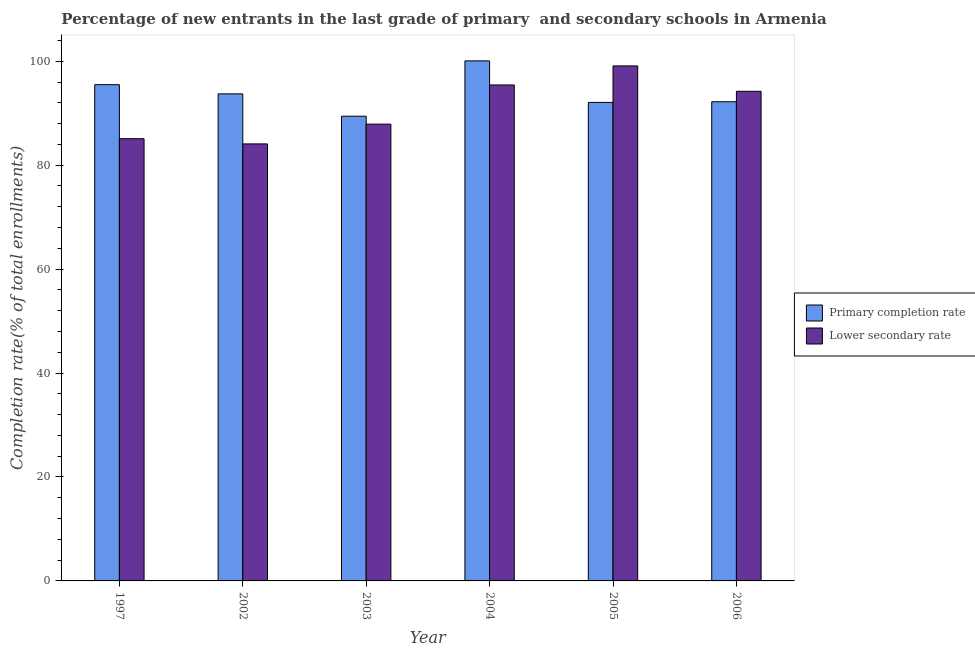How many different coloured bars are there?
Provide a succinct answer. 2. Are the number of bars per tick equal to the number of legend labels?
Your answer should be compact. Yes. Are the number of bars on each tick of the X-axis equal?
Your answer should be compact. Yes. How many bars are there on the 6th tick from the left?
Your answer should be compact. 2. What is the completion rate in primary schools in 1997?
Offer a very short reply. 95.5. Across all years, what is the maximum completion rate in primary schools?
Provide a succinct answer. 100.08. Across all years, what is the minimum completion rate in primary schools?
Make the answer very short. 89.43. In which year was the completion rate in secondary schools minimum?
Give a very brief answer. 2002. What is the total completion rate in primary schools in the graph?
Ensure brevity in your answer.  563.02. What is the difference between the completion rate in primary schools in 2002 and that in 2003?
Offer a terse response. 4.3. What is the difference between the completion rate in secondary schools in 1997 and the completion rate in primary schools in 2002?
Offer a terse response. 1. What is the average completion rate in secondary schools per year?
Your answer should be compact. 90.98. In the year 2006, what is the difference between the completion rate in primary schools and completion rate in secondary schools?
Ensure brevity in your answer.  0. In how many years, is the completion rate in primary schools greater than 64 %?
Offer a terse response. 6. What is the ratio of the completion rate in secondary schools in 2002 to that in 2004?
Your answer should be very brief. 0.88. Is the completion rate in primary schools in 2002 less than that in 2006?
Make the answer very short. No. What is the difference between the highest and the second highest completion rate in secondary schools?
Provide a succinct answer. 3.66. What is the difference between the highest and the lowest completion rate in primary schools?
Ensure brevity in your answer.  10.65. What does the 2nd bar from the left in 2002 represents?
Your response must be concise. Lower secondary rate. What does the 2nd bar from the right in 2006 represents?
Your answer should be compact. Primary completion rate. How many bars are there?
Ensure brevity in your answer.  12. Does the graph contain grids?
Offer a very short reply. No. What is the title of the graph?
Provide a short and direct response. Percentage of new entrants in the last grade of primary  and secondary schools in Armenia. What is the label or title of the Y-axis?
Your response must be concise. Completion rate(% of total enrollments). What is the Completion rate(% of total enrollments) of Primary completion rate in 1997?
Offer a terse response. 95.5. What is the Completion rate(% of total enrollments) of Lower secondary rate in 1997?
Make the answer very short. 85.1. What is the Completion rate(% of total enrollments) in Primary completion rate in 2002?
Provide a short and direct response. 93.73. What is the Completion rate(% of total enrollments) of Lower secondary rate in 2002?
Keep it short and to the point. 84.1. What is the Completion rate(% of total enrollments) in Primary completion rate in 2003?
Offer a terse response. 89.43. What is the Completion rate(% of total enrollments) in Lower secondary rate in 2003?
Provide a succinct answer. 87.91. What is the Completion rate(% of total enrollments) of Primary completion rate in 2004?
Your response must be concise. 100.08. What is the Completion rate(% of total enrollments) in Lower secondary rate in 2004?
Keep it short and to the point. 95.44. What is the Completion rate(% of total enrollments) of Primary completion rate in 2005?
Offer a very short reply. 92.08. What is the Completion rate(% of total enrollments) of Lower secondary rate in 2005?
Ensure brevity in your answer.  99.1. What is the Completion rate(% of total enrollments) in Primary completion rate in 2006?
Keep it short and to the point. 92.21. What is the Completion rate(% of total enrollments) of Lower secondary rate in 2006?
Your answer should be very brief. 94.22. Across all years, what is the maximum Completion rate(% of total enrollments) of Primary completion rate?
Your response must be concise. 100.08. Across all years, what is the maximum Completion rate(% of total enrollments) in Lower secondary rate?
Your response must be concise. 99.1. Across all years, what is the minimum Completion rate(% of total enrollments) of Primary completion rate?
Make the answer very short. 89.43. Across all years, what is the minimum Completion rate(% of total enrollments) in Lower secondary rate?
Your answer should be compact. 84.1. What is the total Completion rate(% of total enrollments) of Primary completion rate in the graph?
Your response must be concise. 563.02. What is the total Completion rate(% of total enrollments) of Lower secondary rate in the graph?
Your response must be concise. 545.87. What is the difference between the Completion rate(% of total enrollments) in Primary completion rate in 1997 and that in 2002?
Your answer should be very brief. 1.77. What is the difference between the Completion rate(% of total enrollments) of Primary completion rate in 1997 and that in 2003?
Keep it short and to the point. 6.07. What is the difference between the Completion rate(% of total enrollments) of Lower secondary rate in 1997 and that in 2003?
Offer a terse response. -2.81. What is the difference between the Completion rate(% of total enrollments) of Primary completion rate in 1997 and that in 2004?
Offer a terse response. -4.58. What is the difference between the Completion rate(% of total enrollments) in Lower secondary rate in 1997 and that in 2004?
Your answer should be compact. -10.34. What is the difference between the Completion rate(% of total enrollments) in Primary completion rate in 1997 and that in 2005?
Provide a short and direct response. 3.42. What is the difference between the Completion rate(% of total enrollments) in Lower secondary rate in 1997 and that in 2005?
Keep it short and to the point. -14.01. What is the difference between the Completion rate(% of total enrollments) of Primary completion rate in 1997 and that in 2006?
Give a very brief answer. 3.29. What is the difference between the Completion rate(% of total enrollments) of Lower secondary rate in 1997 and that in 2006?
Give a very brief answer. -9.12. What is the difference between the Completion rate(% of total enrollments) of Primary completion rate in 2002 and that in 2003?
Provide a succinct answer. 4.3. What is the difference between the Completion rate(% of total enrollments) in Lower secondary rate in 2002 and that in 2003?
Ensure brevity in your answer.  -3.81. What is the difference between the Completion rate(% of total enrollments) in Primary completion rate in 2002 and that in 2004?
Offer a very short reply. -6.35. What is the difference between the Completion rate(% of total enrollments) in Lower secondary rate in 2002 and that in 2004?
Keep it short and to the point. -11.34. What is the difference between the Completion rate(% of total enrollments) in Primary completion rate in 2002 and that in 2005?
Offer a terse response. 1.64. What is the difference between the Completion rate(% of total enrollments) in Lower secondary rate in 2002 and that in 2005?
Offer a terse response. -15.01. What is the difference between the Completion rate(% of total enrollments) in Primary completion rate in 2002 and that in 2006?
Your answer should be very brief. 1.51. What is the difference between the Completion rate(% of total enrollments) in Lower secondary rate in 2002 and that in 2006?
Offer a terse response. -10.13. What is the difference between the Completion rate(% of total enrollments) of Primary completion rate in 2003 and that in 2004?
Provide a short and direct response. -10.65. What is the difference between the Completion rate(% of total enrollments) in Lower secondary rate in 2003 and that in 2004?
Your answer should be compact. -7.53. What is the difference between the Completion rate(% of total enrollments) in Primary completion rate in 2003 and that in 2005?
Offer a very short reply. -2.65. What is the difference between the Completion rate(% of total enrollments) of Lower secondary rate in 2003 and that in 2005?
Offer a very short reply. -11.2. What is the difference between the Completion rate(% of total enrollments) in Primary completion rate in 2003 and that in 2006?
Offer a very short reply. -2.78. What is the difference between the Completion rate(% of total enrollments) of Lower secondary rate in 2003 and that in 2006?
Offer a very short reply. -6.32. What is the difference between the Completion rate(% of total enrollments) of Primary completion rate in 2004 and that in 2005?
Keep it short and to the point. 7.99. What is the difference between the Completion rate(% of total enrollments) in Lower secondary rate in 2004 and that in 2005?
Offer a terse response. -3.66. What is the difference between the Completion rate(% of total enrollments) of Primary completion rate in 2004 and that in 2006?
Provide a short and direct response. 7.86. What is the difference between the Completion rate(% of total enrollments) of Lower secondary rate in 2004 and that in 2006?
Make the answer very short. 1.22. What is the difference between the Completion rate(% of total enrollments) in Primary completion rate in 2005 and that in 2006?
Give a very brief answer. -0.13. What is the difference between the Completion rate(% of total enrollments) in Lower secondary rate in 2005 and that in 2006?
Provide a short and direct response. 4.88. What is the difference between the Completion rate(% of total enrollments) of Primary completion rate in 1997 and the Completion rate(% of total enrollments) of Lower secondary rate in 2002?
Provide a short and direct response. 11.4. What is the difference between the Completion rate(% of total enrollments) of Primary completion rate in 1997 and the Completion rate(% of total enrollments) of Lower secondary rate in 2003?
Offer a very short reply. 7.59. What is the difference between the Completion rate(% of total enrollments) of Primary completion rate in 1997 and the Completion rate(% of total enrollments) of Lower secondary rate in 2004?
Offer a terse response. 0.06. What is the difference between the Completion rate(% of total enrollments) in Primary completion rate in 1997 and the Completion rate(% of total enrollments) in Lower secondary rate in 2005?
Make the answer very short. -3.61. What is the difference between the Completion rate(% of total enrollments) of Primary completion rate in 1997 and the Completion rate(% of total enrollments) of Lower secondary rate in 2006?
Offer a terse response. 1.27. What is the difference between the Completion rate(% of total enrollments) of Primary completion rate in 2002 and the Completion rate(% of total enrollments) of Lower secondary rate in 2003?
Ensure brevity in your answer.  5.82. What is the difference between the Completion rate(% of total enrollments) in Primary completion rate in 2002 and the Completion rate(% of total enrollments) in Lower secondary rate in 2004?
Make the answer very short. -1.72. What is the difference between the Completion rate(% of total enrollments) of Primary completion rate in 2002 and the Completion rate(% of total enrollments) of Lower secondary rate in 2005?
Ensure brevity in your answer.  -5.38. What is the difference between the Completion rate(% of total enrollments) in Primary completion rate in 2002 and the Completion rate(% of total enrollments) in Lower secondary rate in 2006?
Offer a very short reply. -0.5. What is the difference between the Completion rate(% of total enrollments) in Primary completion rate in 2003 and the Completion rate(% of total enrollments) in Lower secondary rate in 2004?
Provide a succinct answer. -6.01. What is the difference between the Completion rate(% of total enrollments) of Primary completion rate in 2003 and the Completion rate(% of total enrollments) of Lower secondary rate in 2005?
Provide a short and direct response. -9.68. What is the difference between the Completion rate(% of total enrollments) of Primary completion rate in 2003 and the Completion rate(% of total enrollments) of Lower secondary rate in 2006?
Offer a terse response. -4.8. What is the difference between the Completion rate(% of total enrollments) of Primary completion rate in 2004 and the Completion rate(% of total enrollments) of Lower secondary rate in 2005?
Provide a succinct answer. 0.97. What is the difference between the Completion rate(% of total enrollments) of Primary completion rate in 2004 and the Completion rate(% of total enrollments) of Lower secondary rate in 2006?
Keep it short and to the point. 5.85. What is the difference between the Completion rate(% of total enrollments) of Primary completion rate in 2005 and the Completion rate(% of total enrollments) of Lower secondary rate in 2006?
Keep it short and to the point. -2.14. What is the average Completion rate(% of total enrollments) in Primary completion rate per year?
Provide a succinct answer. 93.84. What is the average Completion rate(% of total enrollments) in Lower secondary rate per year?
Provide a short and direct response. 90.98. In the year 1997, what is the difference between the Completion rate(% of total enrollments) of Primary completion rate and Completion rate(% of total enrollments) of Lower secondary rate?
Your answer should be very brief. 10.4. In the year 2002, what is the difference between the Completion rate(% of total enrollments) of Primary completion rate and Completion rate(% of total enrollments) of Lower secondary rate?
Give a very brief answer. 9.63. In the year 2003, what is the difference between the Completion rate(% of total enrollments) in Primary completion rate and Completion rate(% of total enrollments) in Lower secondary rate?
Provide a short and direct response. 1.52. In the year 2004, what is the difference between the Completion rate(% of total enrollments) in Primary completion rate and Completion rate(% of total enrollments) in Lower secondary rate?
Your response must be concise. 4.63. In the year 2005, what is the difference between the Completion rate(% of total enrollments) in Primary completion rate and Completion rate(% of total enrollments) in Lower secondary rate?
Provide a succinct answer. -7.02. In the year 2006, what is the difference between the Completion rate(% of total enrollments) in Primary completion rate and Completion rate(% of total enrollments) in Lower secondary rate?
Offer a very short reply. -2.01. What is the ratio of the Completion rate(% of total enrollments) of Primary completion rate in 1997 to that in 2002?
Ensure brevity in your answer.  1.02. What is the ratio of the Completion rate(% of total enrollments) of Lower secondary rate in 1997 to that in 2002?
Your answer should be compact. 1.01. What is the ratio of the Completion rate(% of total enrollments) of Primary completion rate in 1997 to that in 2003?
Offer a terse response. 1.07. What is the ratio of the Completion rate(% of total enrollments) in Lower secondary rate in 1997 to that in 2003?
Your answer should be compact. 0.97. What is the ratio of the Completion rate(% of total enrollments) in Primary completion rate in 1997 to that in 2004?
Ensure brevity in your answer.  0.95. What is the ratio of the Completion rate(% of total enrollments) of Lower secondary rate in 1997 to that in 2004?
Your answer should be compact. 0.89. What is the ratio of the Completion rate(% of total enrollments) in Primary completion rate in 1997 to that in 2005?
Your answer should be compact. 1.04. What is the ratio of the Completion rate(% of total enrollments) of Lower secondary rate in 1997 to that in 2005?
Provide a short and direct response. 0.86. What is the ratio of the Completion rate(% of total enrollments) in Primary completion rate in 1997 to that in 2006?
Keep it short and to the point. 1.04. What is the ratio of the Completion rate(% of total enrollments) of Lower secondary rate in 1997 to that in 2006?
Offer a terse response. 0.9. What is the ratio of the Completion rate(% of total enrollments) of Primary completion rate in 2002 to that in 2003?
Give a very brief answer. 1.05. What is the ratio of the Completion rate(% of total enrollments) of Lower secondary rate in 2002 to that in 2003?
Keep it short and to the point. 0.96. What is the ratio of the Completion rate(% of total enrollments) in Primary completion rate in 2002 to that in 2004?
Offer a terse response. 0.94. What is the ratio of the Completion rate(% of total enrollments) in Lower secondary rate in 2002 to that in 2004?
Keep it short and to the point. 0.88. What is the ratio of the Completion rate(% of total enrollments) of Primary completion rate in 2002 to that in 2005?
Your response must be concise. 1.02. What is the ratio of the Completion rate(% of total enrollments) in Lower secondary rate in 2002 to that in 2005?
Provide a short and direct response. 0.85. What is the ratio of the Completion rate(% of total enrollments) in Primary completion rate in 2002 to that in 2006?
Ensure brevity in your answer.  1.02. What is the ratio of the Completion rate(% of total enrollments) in Lower secondary rate in 2002 to that in 2006?
Ensure brevity in your answer.  0.89. What is the ratio of the Completion rate(% of total enrollments) in Primary completion rate in 2003 to that in 2004?
Give a very brief answer. 0.89. What is the ratio of the Completion rate(% of total enrollments) of Lower secondary rate in 2003 to that in 2004?
Your answer should be very brief. 0.92. What is the ratio of the Completion rate(% of total enrollments) in Primary completion rate in 2003 to that in 2005?
Make the answer very short. 0.97. What is the ratio of the Completion rate(% of total enrollments) of Lower secondary rate in 2003 to that in 2005?
Provide a succinct answer. 0.89. What is the ratio of the Completion rate(% of total enrollments) in Primary completion rate in 2003 to that in 2006?
Provide a succinct answer. 0.97. What is the ratio of the Completion rate(% of total enrollments) of Lower secondary rate in 2003 to that in 2006?
Give a very brief answer. 0.93. What is the ratio of the Completion rate(% of total enrollments) in Primary completion rate in 2004 to that in 2005?
Ensure brevity in your answer.  1.09. What is the ratio of the Completion rate(% of total enrollments) of Lower secondary rate in 2004 to that in 2005?
Offer a terse response. 0.96. What is the ratio of the Completion rate(% of total enrollments) in Primary completion rate in 2004 to that in 2006?
Offer a terse response. 1.09. What is the ratio of the Completion rate(% of total enrollments) of Lower secondary rate in 2004 to that in 2006?
Offer a very short reply. 1.01. What is the ratio of the Completion rate(% of total enrollments) of Lower secondary rate in 2005 to that in 2006?
Your response must be concise. 1.05. What is the difference between the highest and the second highest Completion rate(% of total enrollments) of Primary completion rate?
Provide a succinct answer. 4.58. What is the difference between the highest and the second highest Completion rate(% of total enrollments) of Lower secondary rate?
Your answer should be compact. 3.66. What is the difference between the highest and the lowest Completion rate(% of total enrollments) of Primary completion rate?
Ensure brevity in your answer.  10.65. What is the difference between the highest and the lowest Completion rate(% of total enrollments) of Lower secondary rate?
Provide a short and direct response. 15.01. 